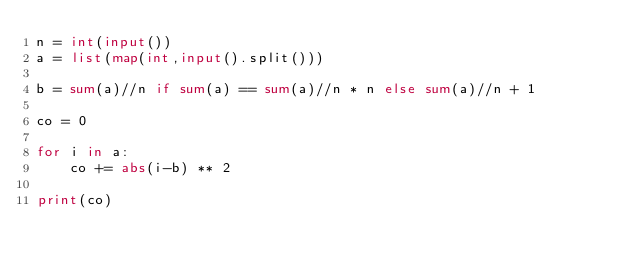<code> <loc_0><loc_0><loc_500><loc_500><_Python_>n = int(input())
a = list(map(int,input().split()))

b = sum(a)//n if sum(a) == sum(a)//n * n else sum(a)//n + 1

co = 0

for i in a:
    co += abs(i-b) ** 2

print(co)</code> 